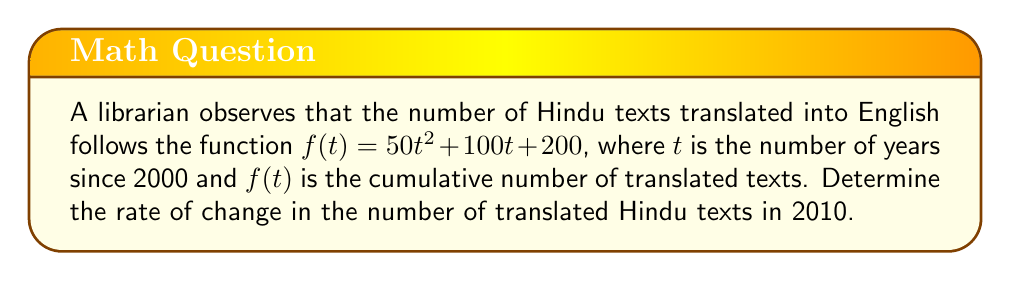Can you solve this math problem? To find the rate of change in the number of translated Hindu texts in 2010, we need to follow these steps:

1) The given function is $f(t) = 50t^2 + 100t + 200$

2) The rate of change at any point is given by the derivative of the function. Let's call this $f'(t)$.

3) To find $f'(t)$, we differentiate $f(t)$ with respect to $t$:
   
   $f'(t) = \frac{d}{dt}(50t^2 + 100t + 200)$
   
   $f'(t) = 100t + 100$

4) Now, we need to find the value of $t$ for the year 2010. Since $t$ is the number of years since 2000:
   
   $t_{2010} = 2010 - 2000 = 10$

5) To find the rate of change in 2010, we substitute $t = 10$ into $f'(t)$:
   
   $f'(10) = 100(10) + 100 = 1000 + 100 = 1100$

Therefore, the rate of change in the number of translated Hindu texts in 2010 was 1100 texts per year.
Answer: 1100 texts/year 